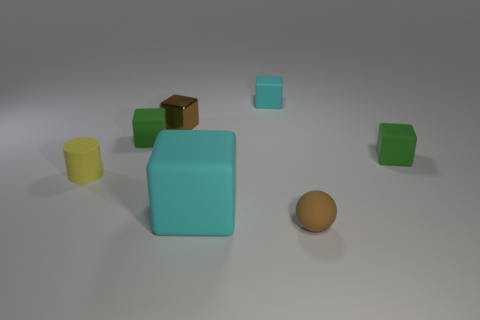Is there anything else that has the same size as the yellow rubber object?
Ensure brevity in your answer.  Yes. There is a object that is the same color as the rubber ball; what is its size?
Your answer should be very brief. Small. What is the shape of the brown metallic thing?
Your response must be concise. Cube. What is the shape of the green rubber thing that is left of the tiny object right of the tiny brown ball?
Provide a succinct answer. Cube. Is the brown thing on the right side of the small brown metallic cube made of the same material as the tiny yellow cylinder?
Your answer should be very brief. Yes. How many green objects are either large matte things or cylinders?
Make the answer very short. 0. Is there a small ball of the same color as the tiny rubber cylinder?
Keep it short and to the point. No. Is there a tiny gray cube that has the same material as the large cyan cube?
Your answer should be very brief. No. What is the shape of the thing that is both in front of the small rubber cylinder and behind the brown ball?
Your response must be concise. Cube. What number of small things are brown matte spheres or yellow rubber cylinders?
Your answer should be compact. 2. 